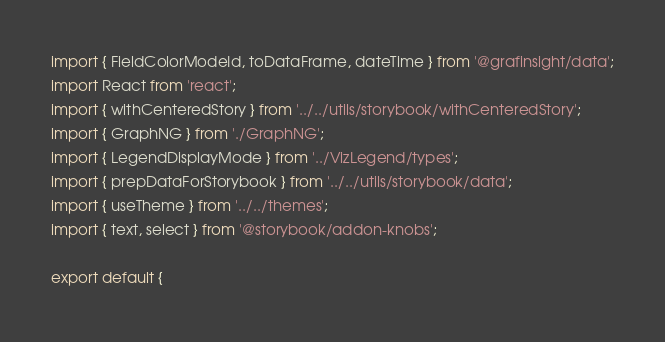<code> <loc_0><loc_0><loc_500><loc_500><_TypeScript_>import { FieldColorModeId, toDataFrame, dateTime } from '@grafinsight/data';
import React from 'react';
import { withCenteredStory } from '../../utils/storybook/withCenteredStory';
import { GraphNG } from './GraphNG';
import { LegendDisplayMode } from '../VizLegend/types';
import { prepDataForStorybook } from '../../utils/storybook/data';
import { useTheme } from '../../themes';
import { text, select } from '@storybook/addon-knobs';

export default {</code> 